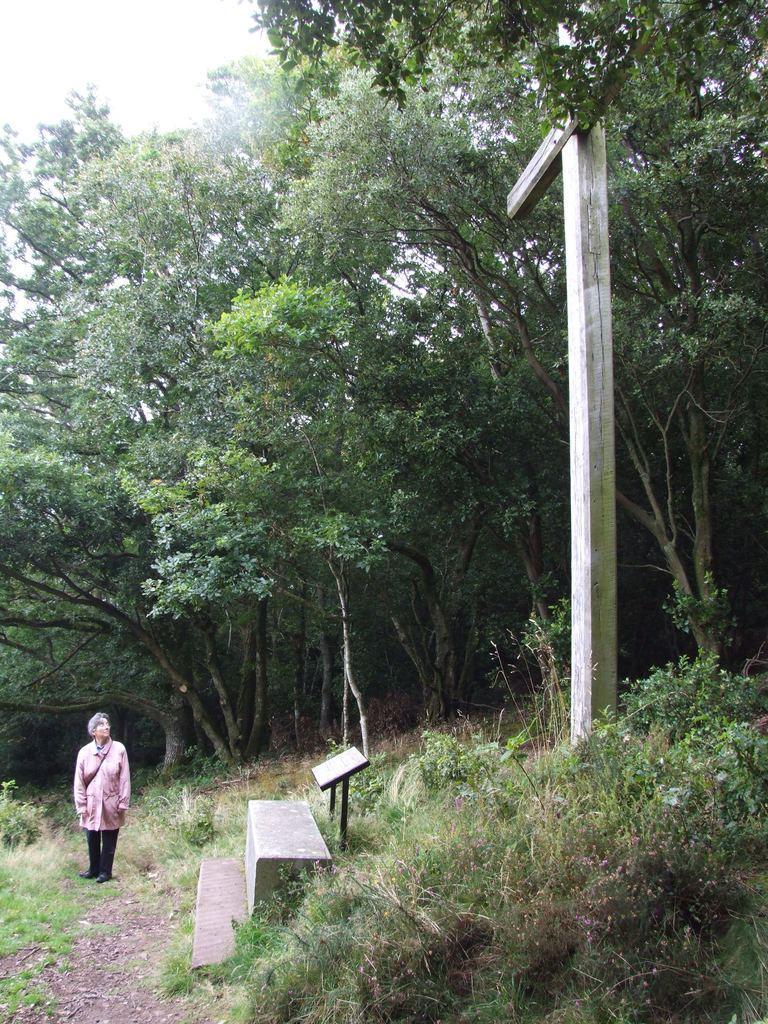Please provide a concise description of this image. In this image I can see a person is standing on grass, bench, plans, board and a pole. In the background I can see trees and the sky. This image is taken may be in the forest. 